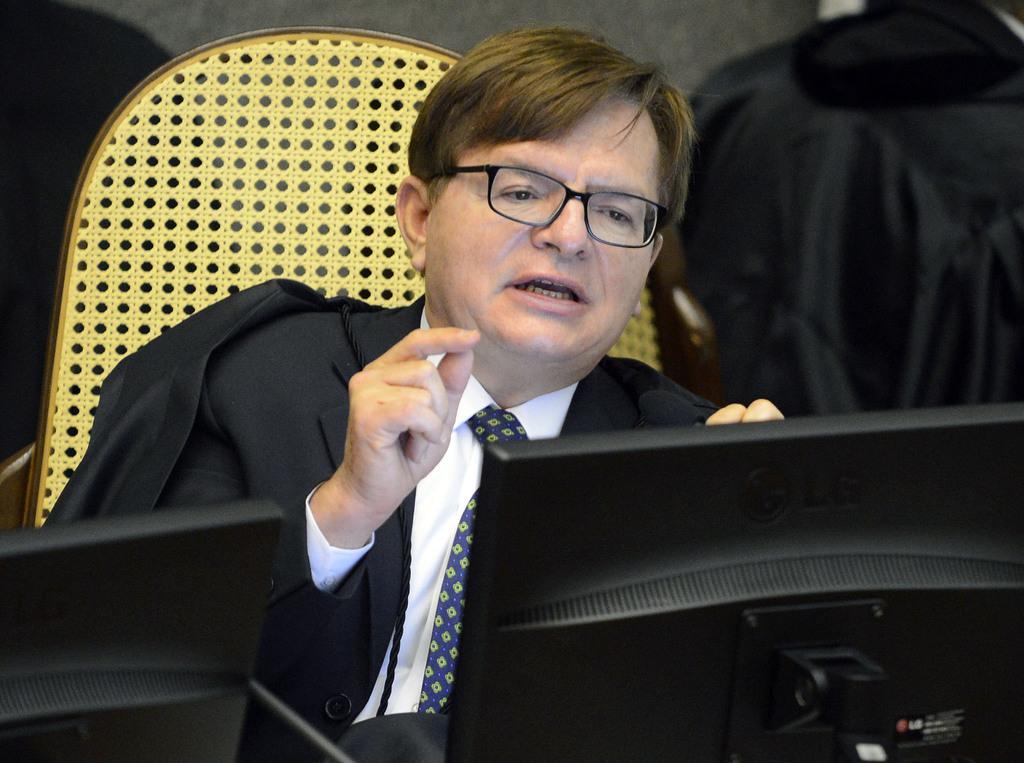Describe this image in one or two sentences. This is a zoomed in picture. In the foreground we can see the monitors. In the center there is a person wearing suit, sitting on the chair and seems to be talking. In the background we can see the wall and some other objects. 